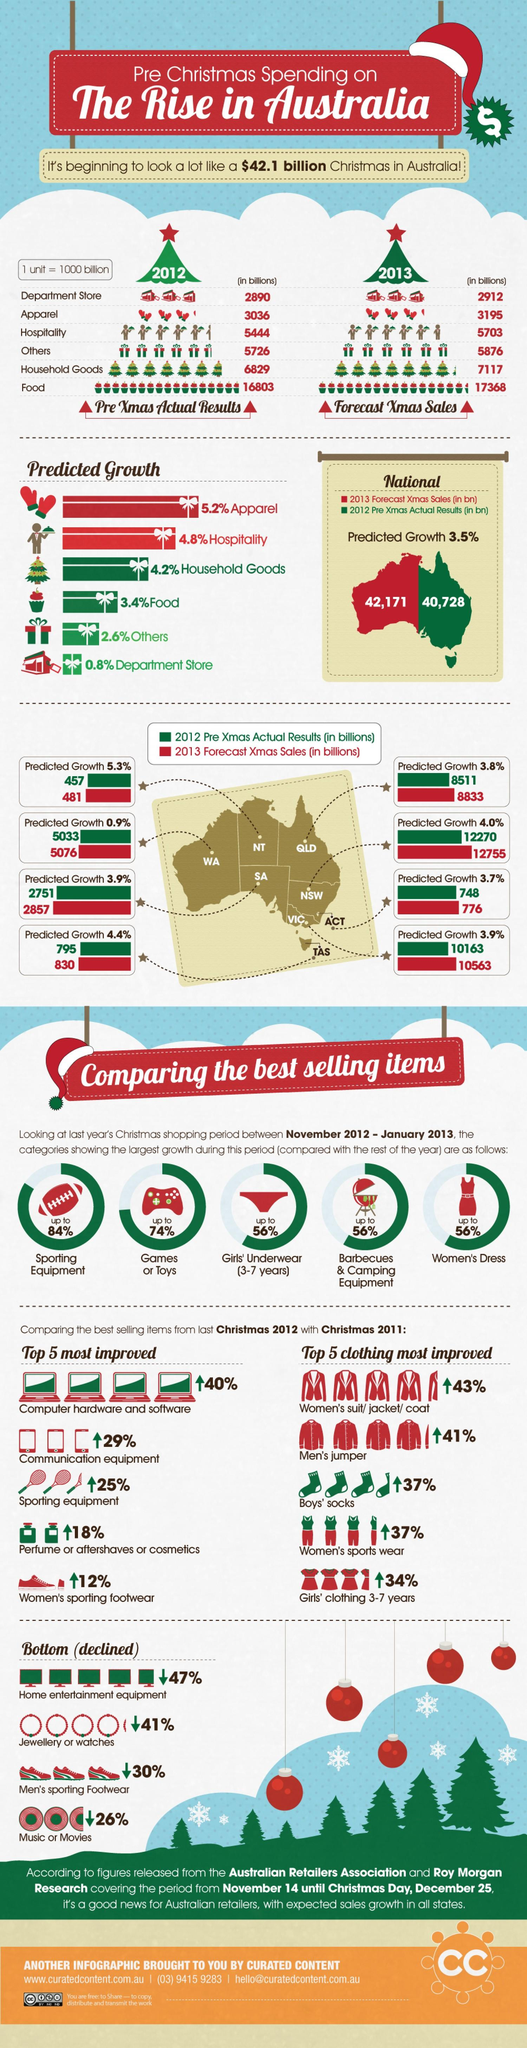Indicate a few pertinent items in this graphic. In 2012, the state with the lowest recorded Christmas sales was the Northern Territory. In the period 2012-2013, there was a growth of 56% in the number of categories. The number of Christmas sales in 2013 was greater than the number of Christmas sales in 2012. Specifically, the number of Christmas sales in 2013 was 1,443 while the number of Christmas sales in 2012 was 1,443. What is the predicted increase in the category of "Others" in 2013? The predicted increase is 5,876. Northeastern states have the highest forecast for sales growth, according to recent data. 